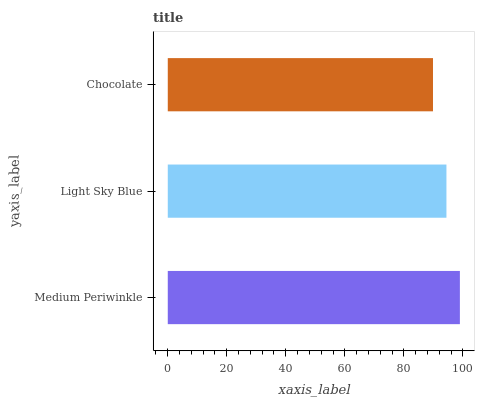Is Chocolate the minimum?
Answer yes or no. Yes. Is Medium Periwinkle the maximum?
Answer yes or no. Yes. Is Light Sky Blue the minimum?
Answer yes or no. No. Is Light Sky Blue the maximum?
Answer yes or no. No. Is Medium Periwinkle greater than Light Sky Blue?
Answer yes or no. Yes. Is Light Sky Blue less than Medium Periwinkle?
Answer yes or no. Yes. Is Light Sky Blue greater than Medium Periwinkle?
Answer yes or no. No. Is Medium Periwinkle less than Light Sky Blue?
Answer yes or no. No. Is Light Sky Blue the high median?
Answer yes or no. Yes. Is Light Sky Blue the low median?
Answer yes or no. Yes. Is Medium Periwinkle the high median?
Answer yes or no. No. Is Chocolate the low median?
Answer yes or no. No. 